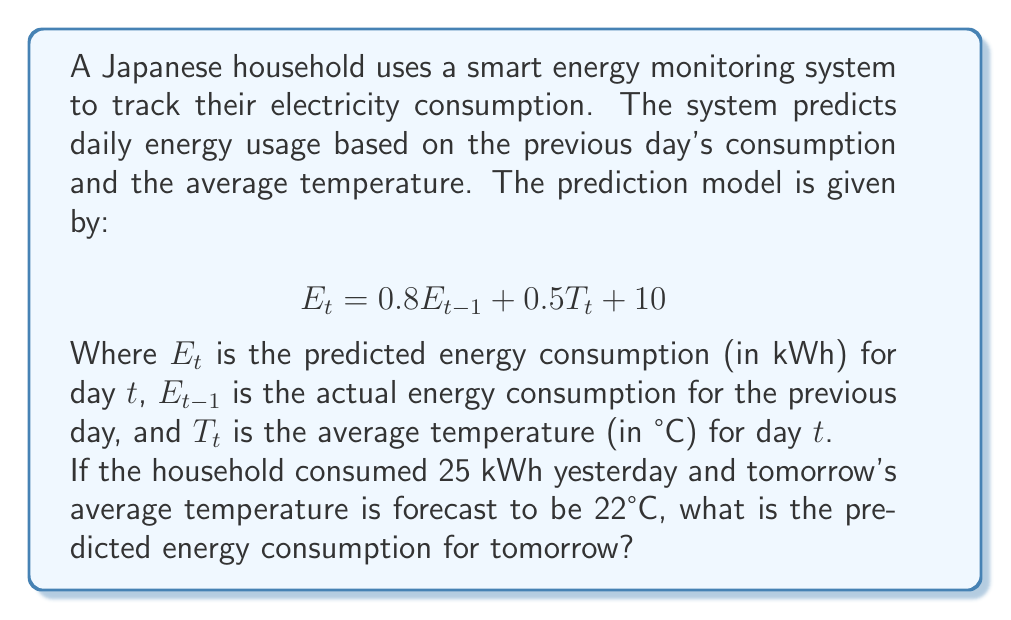Show me your answer to this math problem. To solve this problem, we'll follow these steps:

1. Identify the given information:
   - Previous day's energy consumption ($E_{t-1}$) = 25 kWh
   - Forecast average temperature for tomorrow ($T_t$) = 22°C
   - Prediction model: $E_t = 0.8E_{t-1} + 0.5T_t + 10$

2. Substitute the known values into the equation:
   $E_t = 0.8(25) + 0.5(22) + 10$

3. Calculate each term:
   - $0.8(25) = 20$
   - $0.5(22) = 11$
   - The constant term is already 10

4. Sum up all the terms:
   $E_t = 20 + 11 + 10 = 41$

Therefore, the predicted energy consumption for tomorrow is 41 kWh.
Answer: 41 kWh 